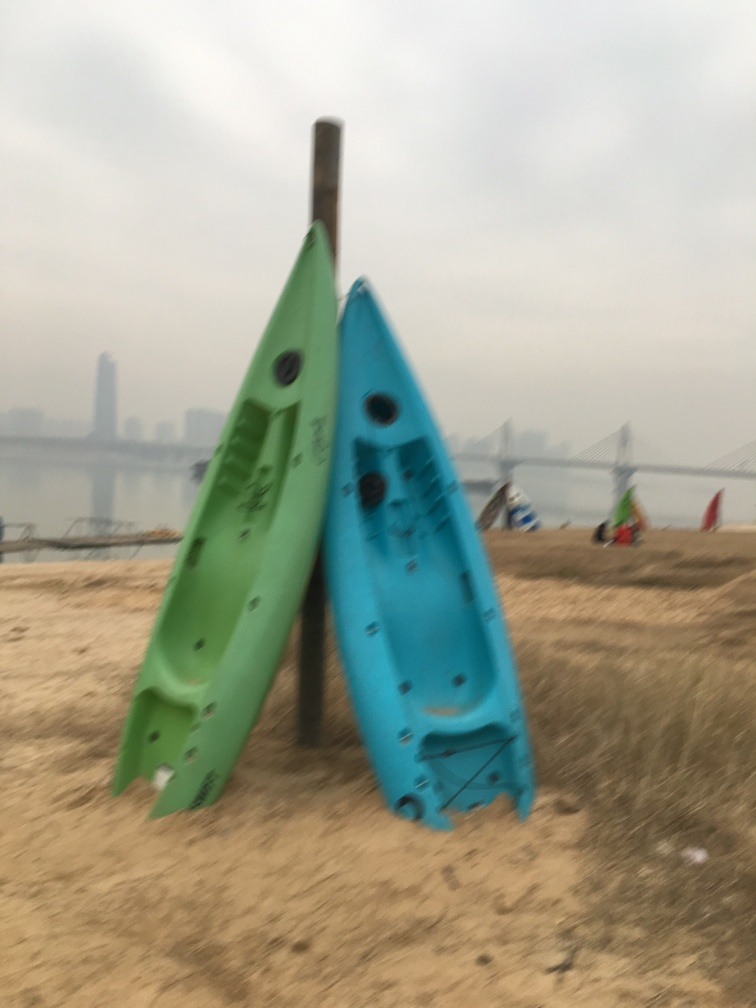What is poorly preserved in the image?
A. The texture and details of the small boat.
B. The motion and dynamism of the small boat.
C. The color and brightness of the small boat.
D. The composition and framing of the small boat. The texture and details of the small boats in the image are poorly preserved due to the apparent blurriness and lack of sharpness. This effect obscures the finer details that would otherwise convey the appearance and condition of the boats more clearly. 